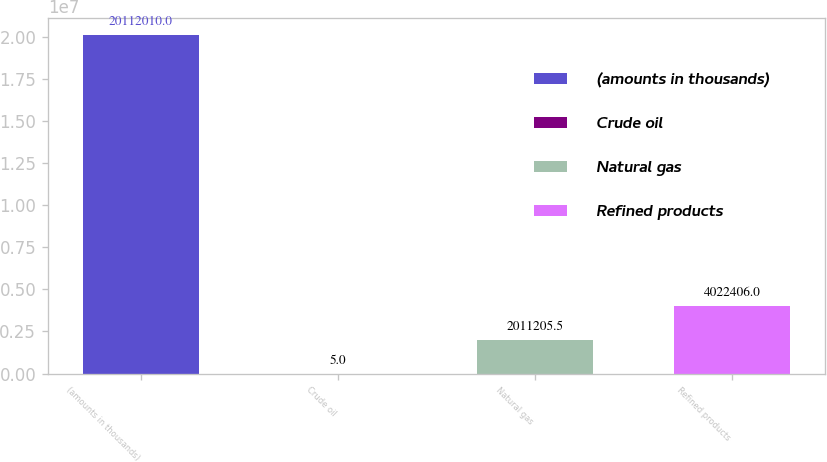<chart> <loc_0><loc_0><loc_500><loc_500><bar_chart><fcel>(amounts in thousands)<fcel>Crude oil<fcel>Natural gas<fcel>Refined products<nl><fcel>2.0112e+07<fcel>5<fcel>2.01121e+06<fcel>4.02241e+06<nl></chart> 